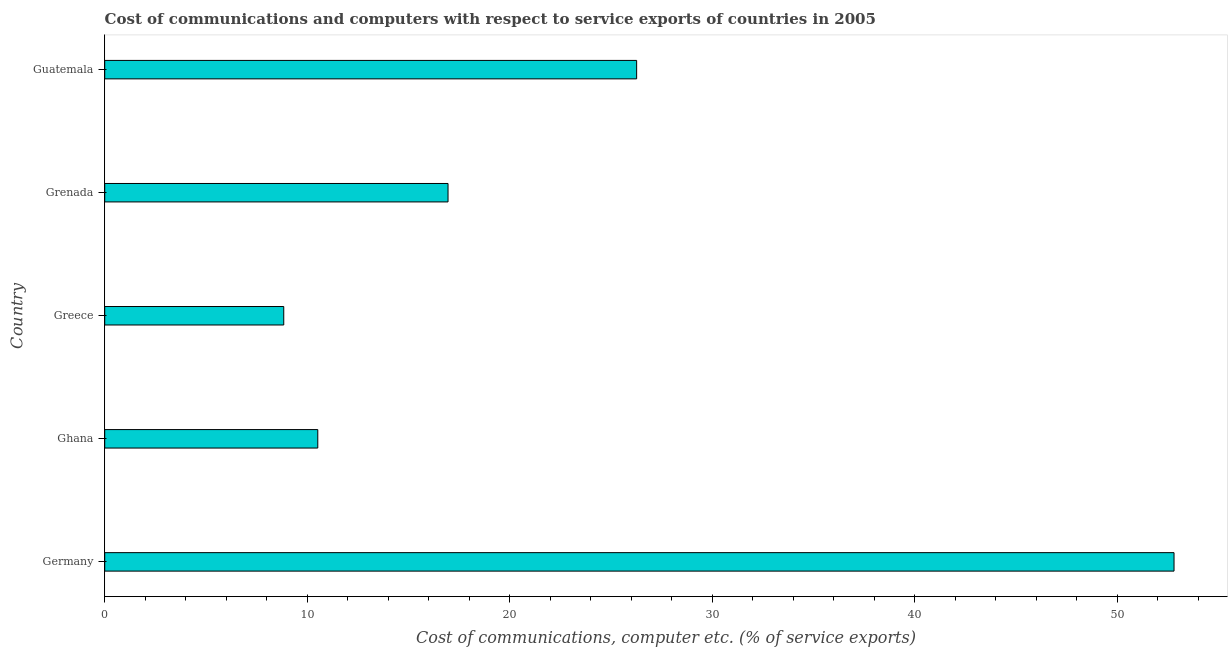Does the graph contain grids?
Your answer should be very brief. No. What is the title of the graph?
Provide a short and direct response. Cost of communications and computers with respect to service exports of countries in 2005. What is the label or title of the X-axis?
Give a very brief answer. Cost of communications, computer etc. (% of service exports). What is the cost of communications and computer in Ghana?
Your response must be concise. 10.52. Across all countries, what is the maximum cost of communications and computer?
Your answer should be very brief. 52.8. Across all countries, what is the minimum cost of communications and computer?
Offer a very short reply. 8.84. In which country was the cost of communications and computer maximum?
Your response must be concise. Germany. In which country was the cost of communications and computer minimum?
Your answer should be very brief. Greece. What is the sum of the cost of communications and computer?
Your answer should be very brief. 115.38. What is the difference between the cost of communications and computer in Ghana and Greece?
Your answer should be compact. 1.68. What is the average cost of communications and computer per country?
Your answer should be compact. 23.08. What is the median cost of communications and computer?
Your answer should be very brief. 16.95. What is the ratio of the cost of communications and computer in Germany to that in Greece?
Keep it short and to the point. 5.97. What is the difference between the highest and the second highest cost of communications and computer?
Keep it short and to the point. 26.54. What is the difference between the highest and the lowest cost of communications and computer?
Keep it short and to the point. 43.96. What is the Cost of communications, computer etc. (% of service exports) of Germany?
Provide a short and direct response. 52.8. What is the Cost of communications, computer etc. (% of service exports) in Ghana?
Keep it short and to the point. 10.52. What is the Cost of communications, computer etc. (% of service exports) in Greece?
Make the answer very short. 8.84. What is the Cost of communications, computer etc. (% of service exports) in Grenada?
Your answer should be compact. 16.95. What is the Cost of communications, computer etc. (% of service exports) of Guatemala?
Make the answer very short. 26.27. What is the difference between the Cost of communications, computer etc. (% of service exports) in Germany and Ghana?
Your answer should be very brief. 42.28. What is the difference between the Cost of communications, computer etc. (% of service exports) in Germany and Greece?
Give a very brief answer. 43.96. What is the difference between the Cost of communications, computer etc. (% of service exports) in Germany and Grenada?
Offer a terse response. 35.85. What is the difference between the Cost of communications, computer etc. (% of service exports) in Germany and Guatemala?
Give a very brief answer. 26.54. What is the difference between the Cost of communications, computer etc. (% of service exports) in Ghana and Greece?
Give a very brief answer. 1.68. What is the difference between the Cost of communications, computer etc. (% of service exports) in Ghana and Grenada?
Make the answer very short. -6.43. What is the difference between the Cost of communications, computer etc. (% of service exports) in Ghana and Guatemala?
Offer a very short reply. -15.74. What is the difference between the Cost of communications, computer etc. (% of service exports) in Greece and Grenada?
Provide a short and direct response. -8.11. What is the difference between the Cost of communications, computer etc. (% of service exports) in Greece and Guatemala?
Provide a succinct answer. -17.42. What is the difference between the Cost of communications, computer etc. (% of service exports) in Grenada and Guatemala?
Your answer should be compact. -9.31. What is the ratio of the Cost of communications, computer etc. (% of service exports) in Germany to that in Ghana?
Offer a very short reply. 5.02. What is the ratio of the Cost of communications, computer etc. (% of service exports) in Germany to that in Greece?
Provide a succinct answer. 5.97. What is the ratio of the Cost of communications, computer etc. (% of service exports) in Germany to that in Grenada?
Offer a terse response. 3.12. What is the ratio of the Cost of communications, computer etc. (% of service exports) in Germany to that in Guatemala?
Your answer should be very brief. 2.01. What is the ratio of the Cost of communications, computer etc. (% of service exports) in Ghana to that in Greece?
Offer a very short reply. 1.19. What is the ratio of the Cost of communications, computer etc. (% of service exports) in Ghana to that in Grenada?
Provide a short and direct response. 0.62. What is the ratio of the Cost of communications, computer etc. (% of service exports) in Ghana to that in Guatemala?
Provide a succinct answer. 0.4. What is the ratio of the Cost of communications, computer etc. (% of service exports) in Greece to that in Grenada?
Provide a short and direct response. 0.52. What is the ratio of the Cost of communications, computer etc. (% of service exports) in Greece to that in Guatemala?
Provide a succinct answer. 0.34. What is the ratio of the Cost of communications, computer etc. (% of service exports) in Grenada to that in Guatemala?
Offer a terse response. 0.65. 